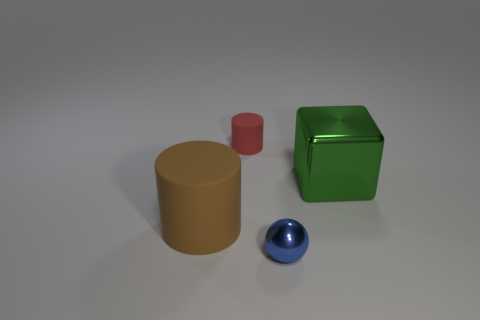Which object appears the smallest and what is its color? The smallest object appears to be the blue sphere. 